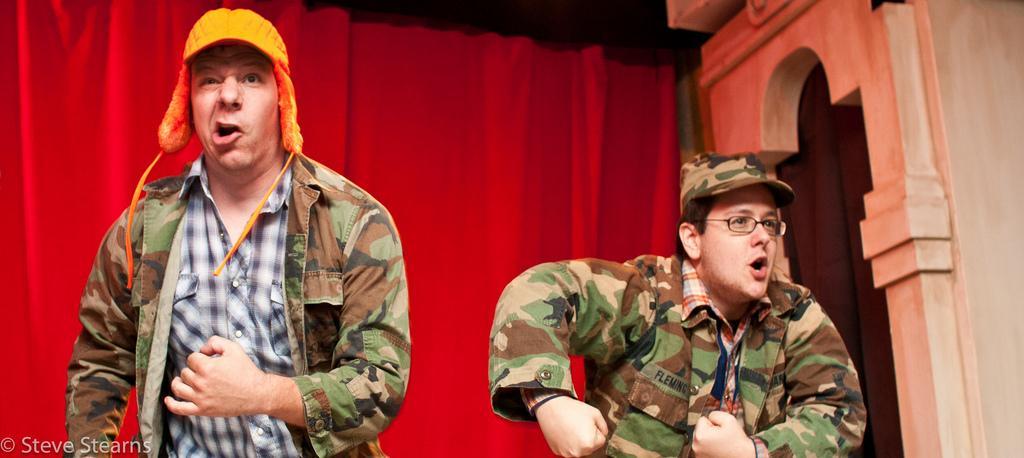Can you describe this image briefly? In this image in front there are two people. Behind them there are curtains. There is some text on the left side of the image. On the right side of the image there is a wall. 